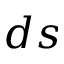Convert formula to latex. <formula><loc_0><loc_0><loc_500><loc_500>d s</formula> 